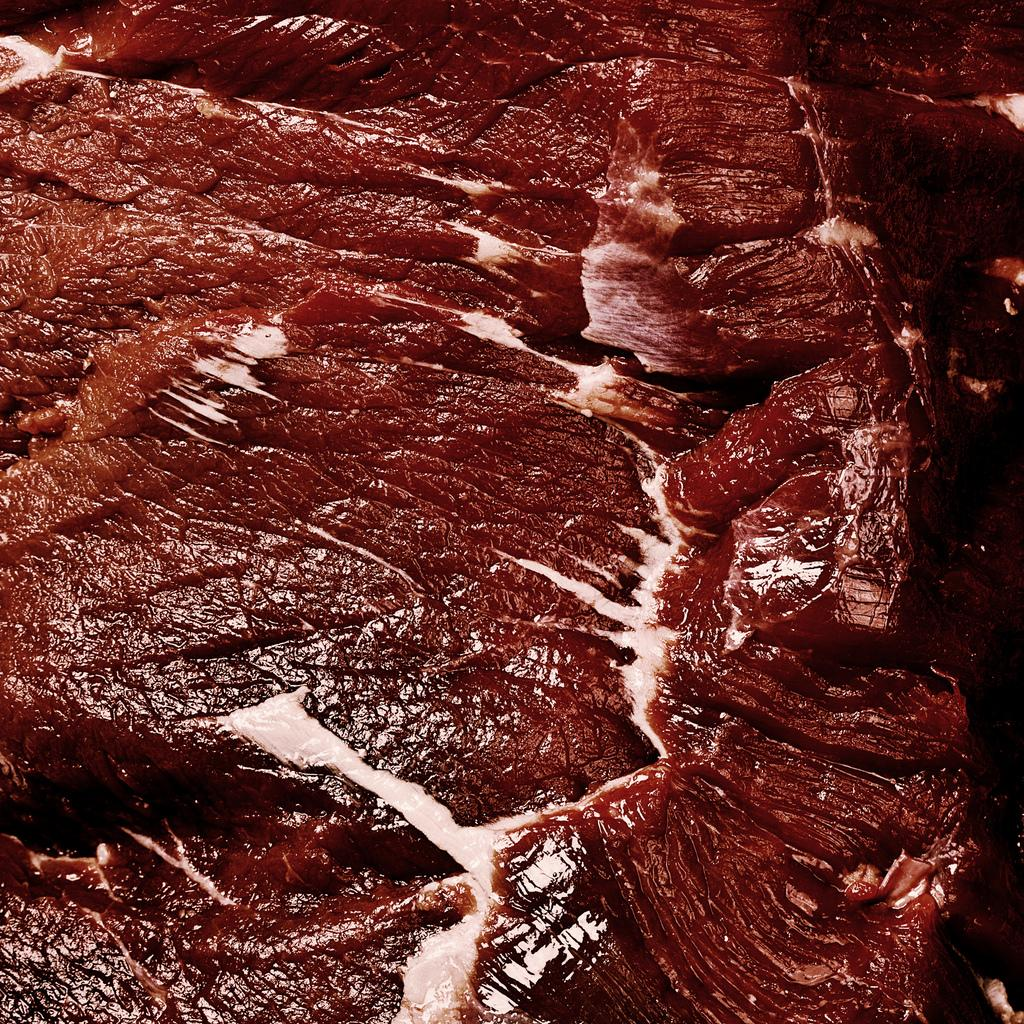What type of food is visible in the image? There is meat in the image. What color is the meat in the image? The meat is red in color. What type of power source is connected to the wire in the image? There is no wire or power source present in the image; it only features meat. 